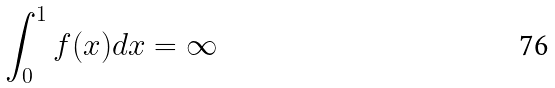<formula> <loc_0><loc_0><loc_500><loc_500>\int _ { 0 } ^ { 1 } f ( x ) d x = \infty</formula> 